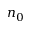<formula> <loc_0><loc_0><loc_500><loc_500>n _ { 0 }</formula> 